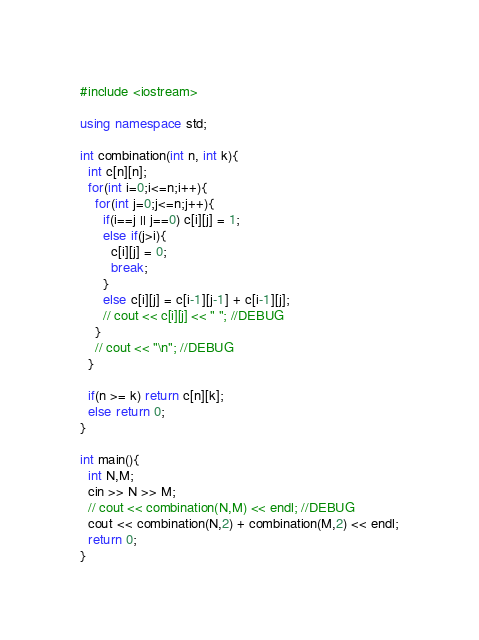Convert code to text. <code><loc_0><loc_0><loc_500><loc_500><_C++_>#include <iostream>

using namespace std;

int combination(int n, int k){
  int c[n][n];
  for(int i=0;i<=n;i++){
    for(int j=0;j<=n;j++){
      if(i==j || j==0) c[i][j] = 1;
      else if(j>i){
        c[i][j] = 0;
        break;
      }
      else c[i][j] = c[i-1][j-1] + c[i-1][j];
      // cout << c[i][j] << " "; //DEBUG
    }
    // cout << "\n"; //DEBUG
  }

  if(n >= k) return c[n][k];
  else return 0;
}

int main(){
  int N,M;
  cin >> N >> M;
  // cout << combination(N,M) << endl; //DEBUG
  cout << combination(N,2) + combination(M,2) << endl;
  return 0;
}
</code> 